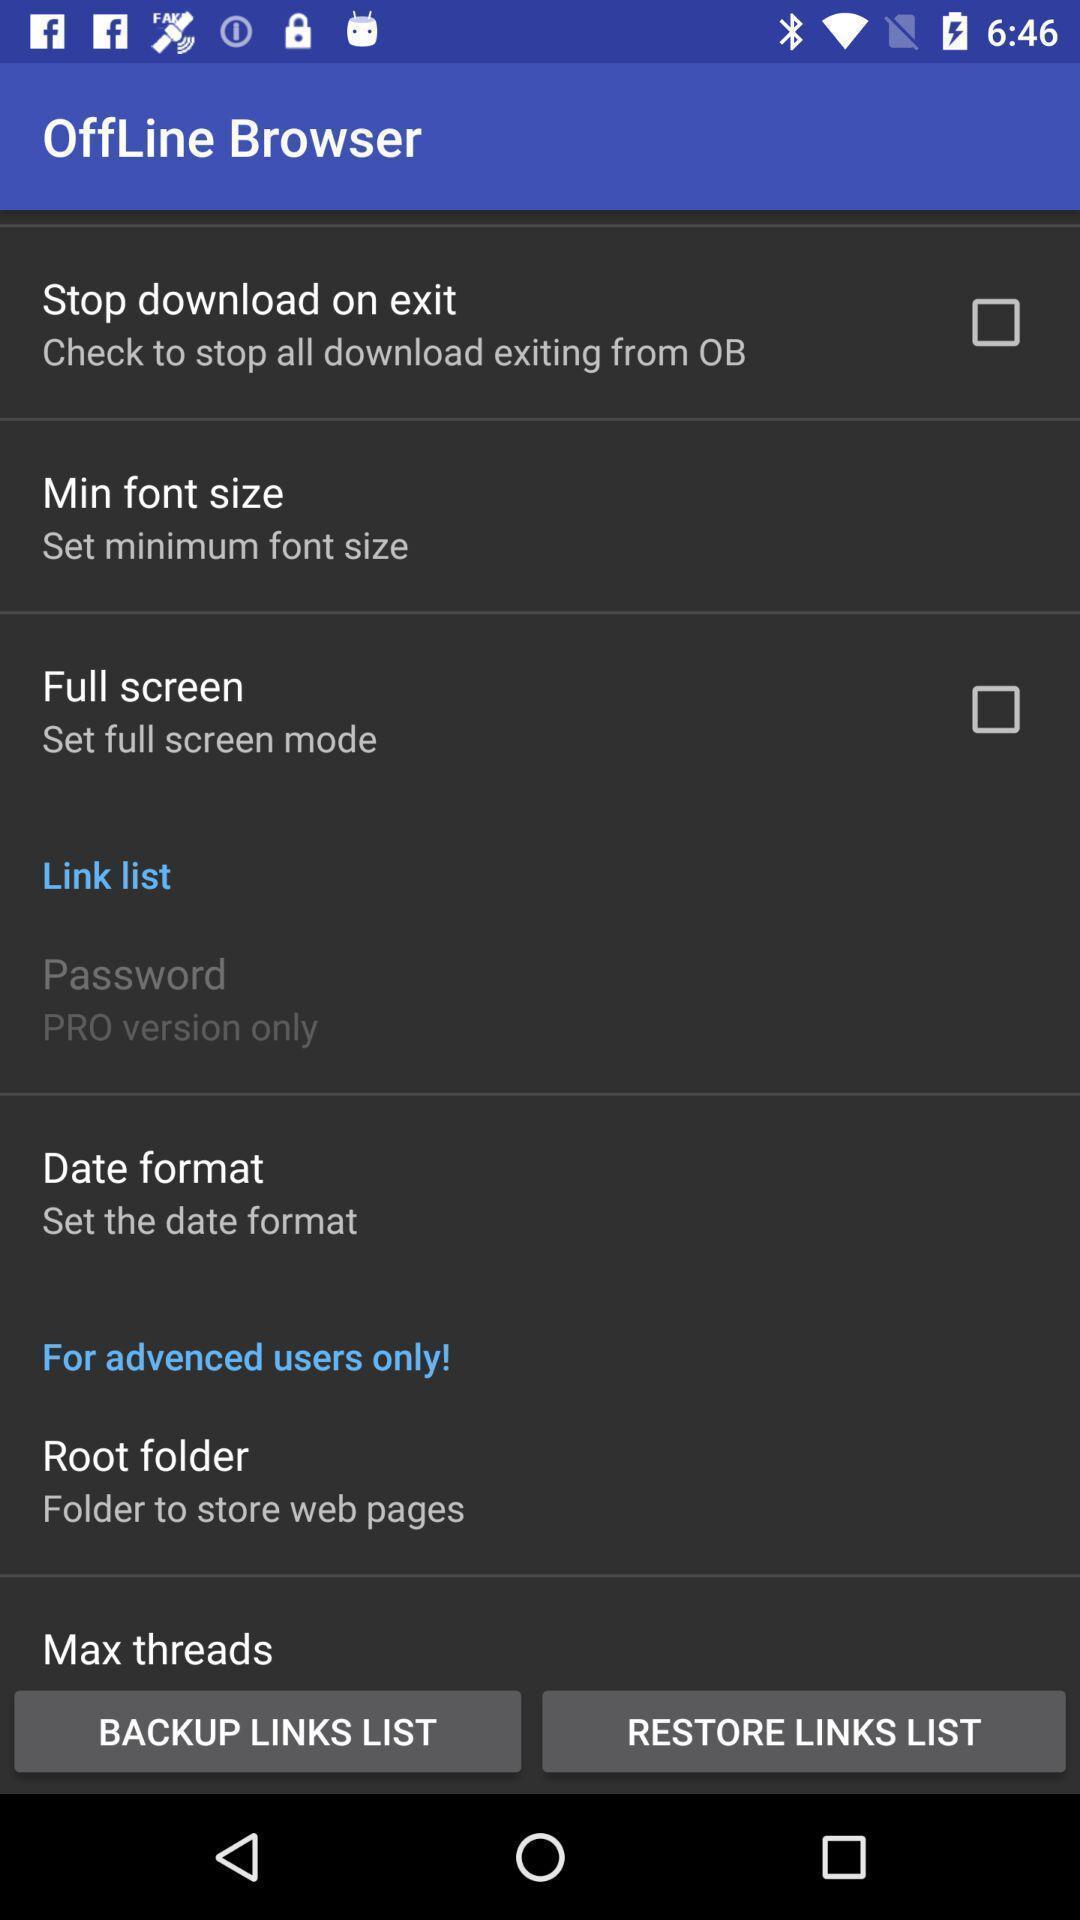Please provide a description for this image. Various offline browser options in the application. 